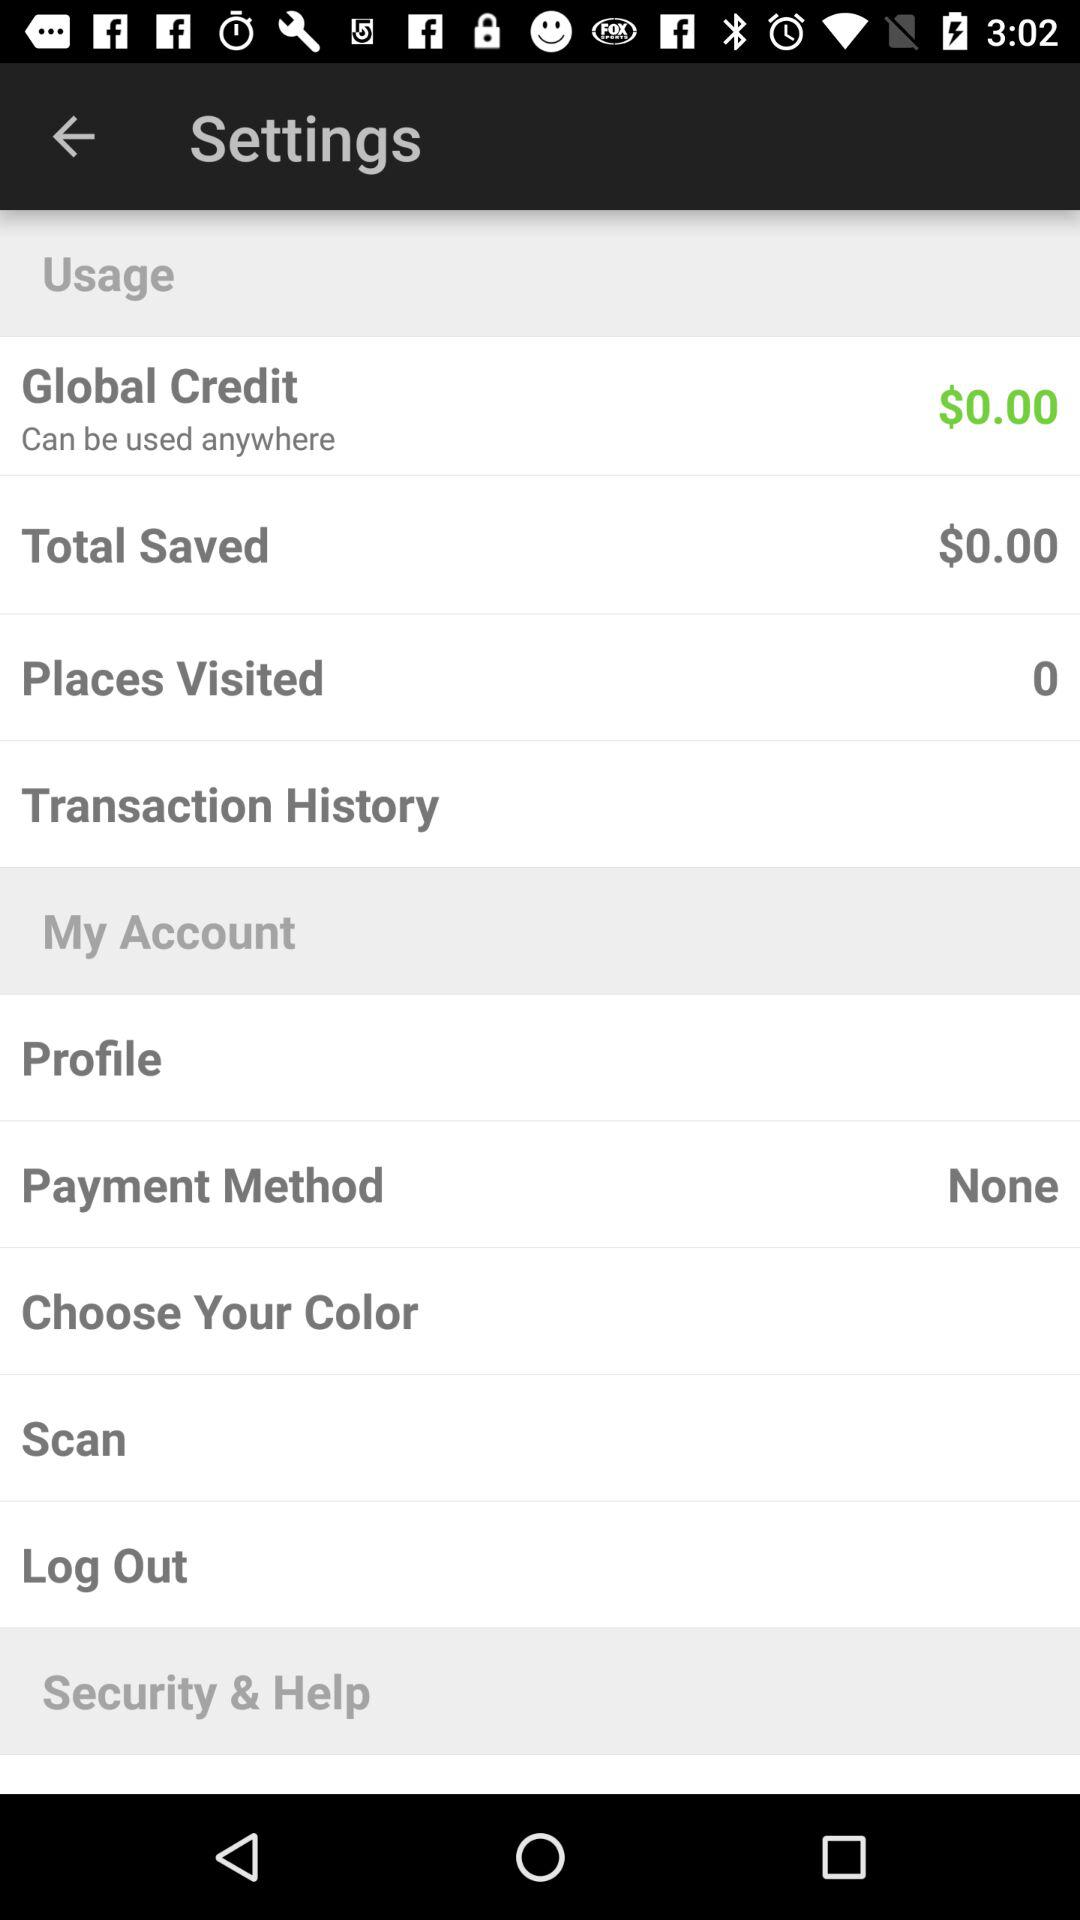How much money is saved? The saved money is $0. 